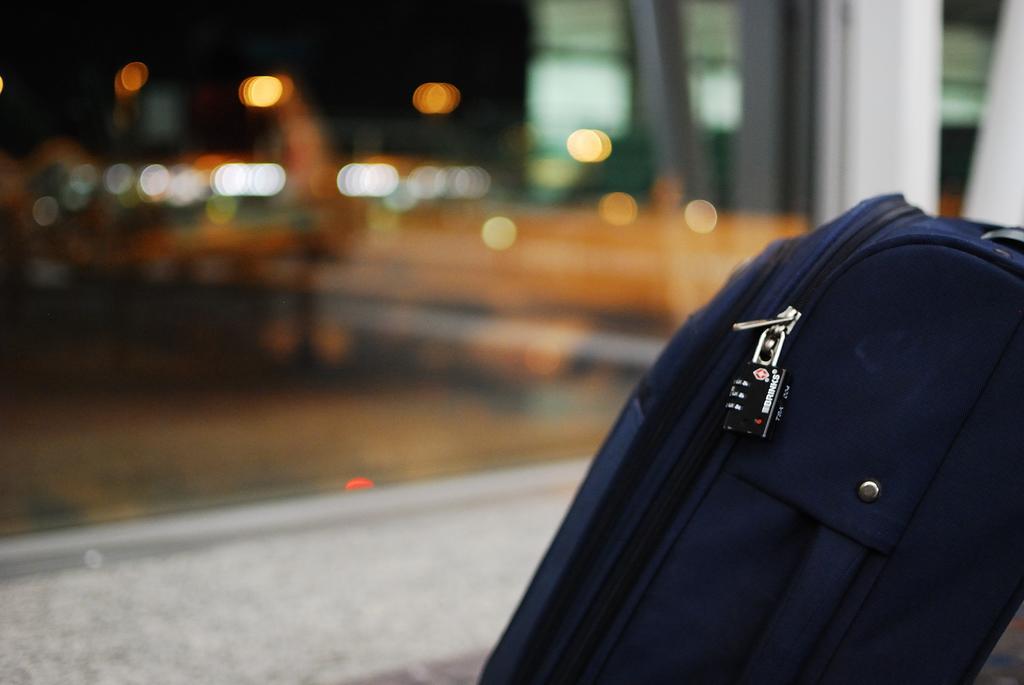Please provide a concise description of this image. There is a bag in the foreground of the image. The background of the image is blurry. 